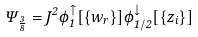<formula> <loc_0><loc_0><loc_500><loc_500>\Psi _ { \frac { 3 } { 8 } } = J ^ { 2 } \phi _ { 1 } ^ { \uparrow } [ \{ w _ { r } \} ] \phi _ { 1 / 2 } ^ { \downarrow } [ \{ z _ { i } \} ]</formula> 